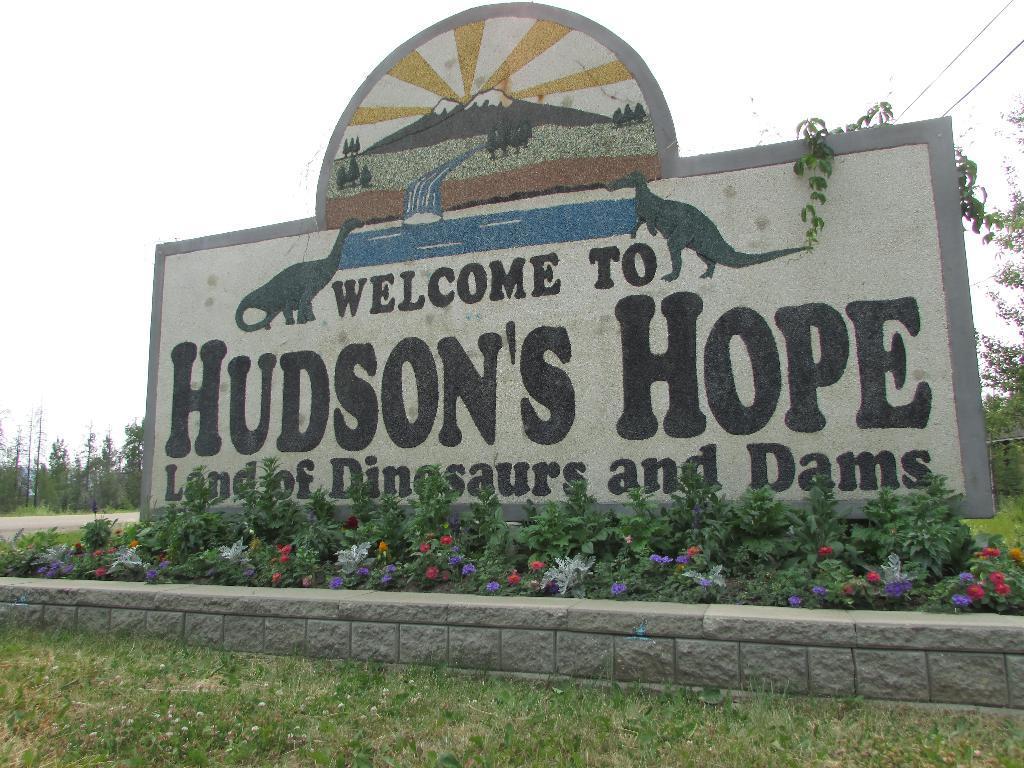How would you summarize this image in a sentence or two? In this picture I can see a stone wall something written on it. I can see green grass. I can see flower plants. I can see trees in the background. 